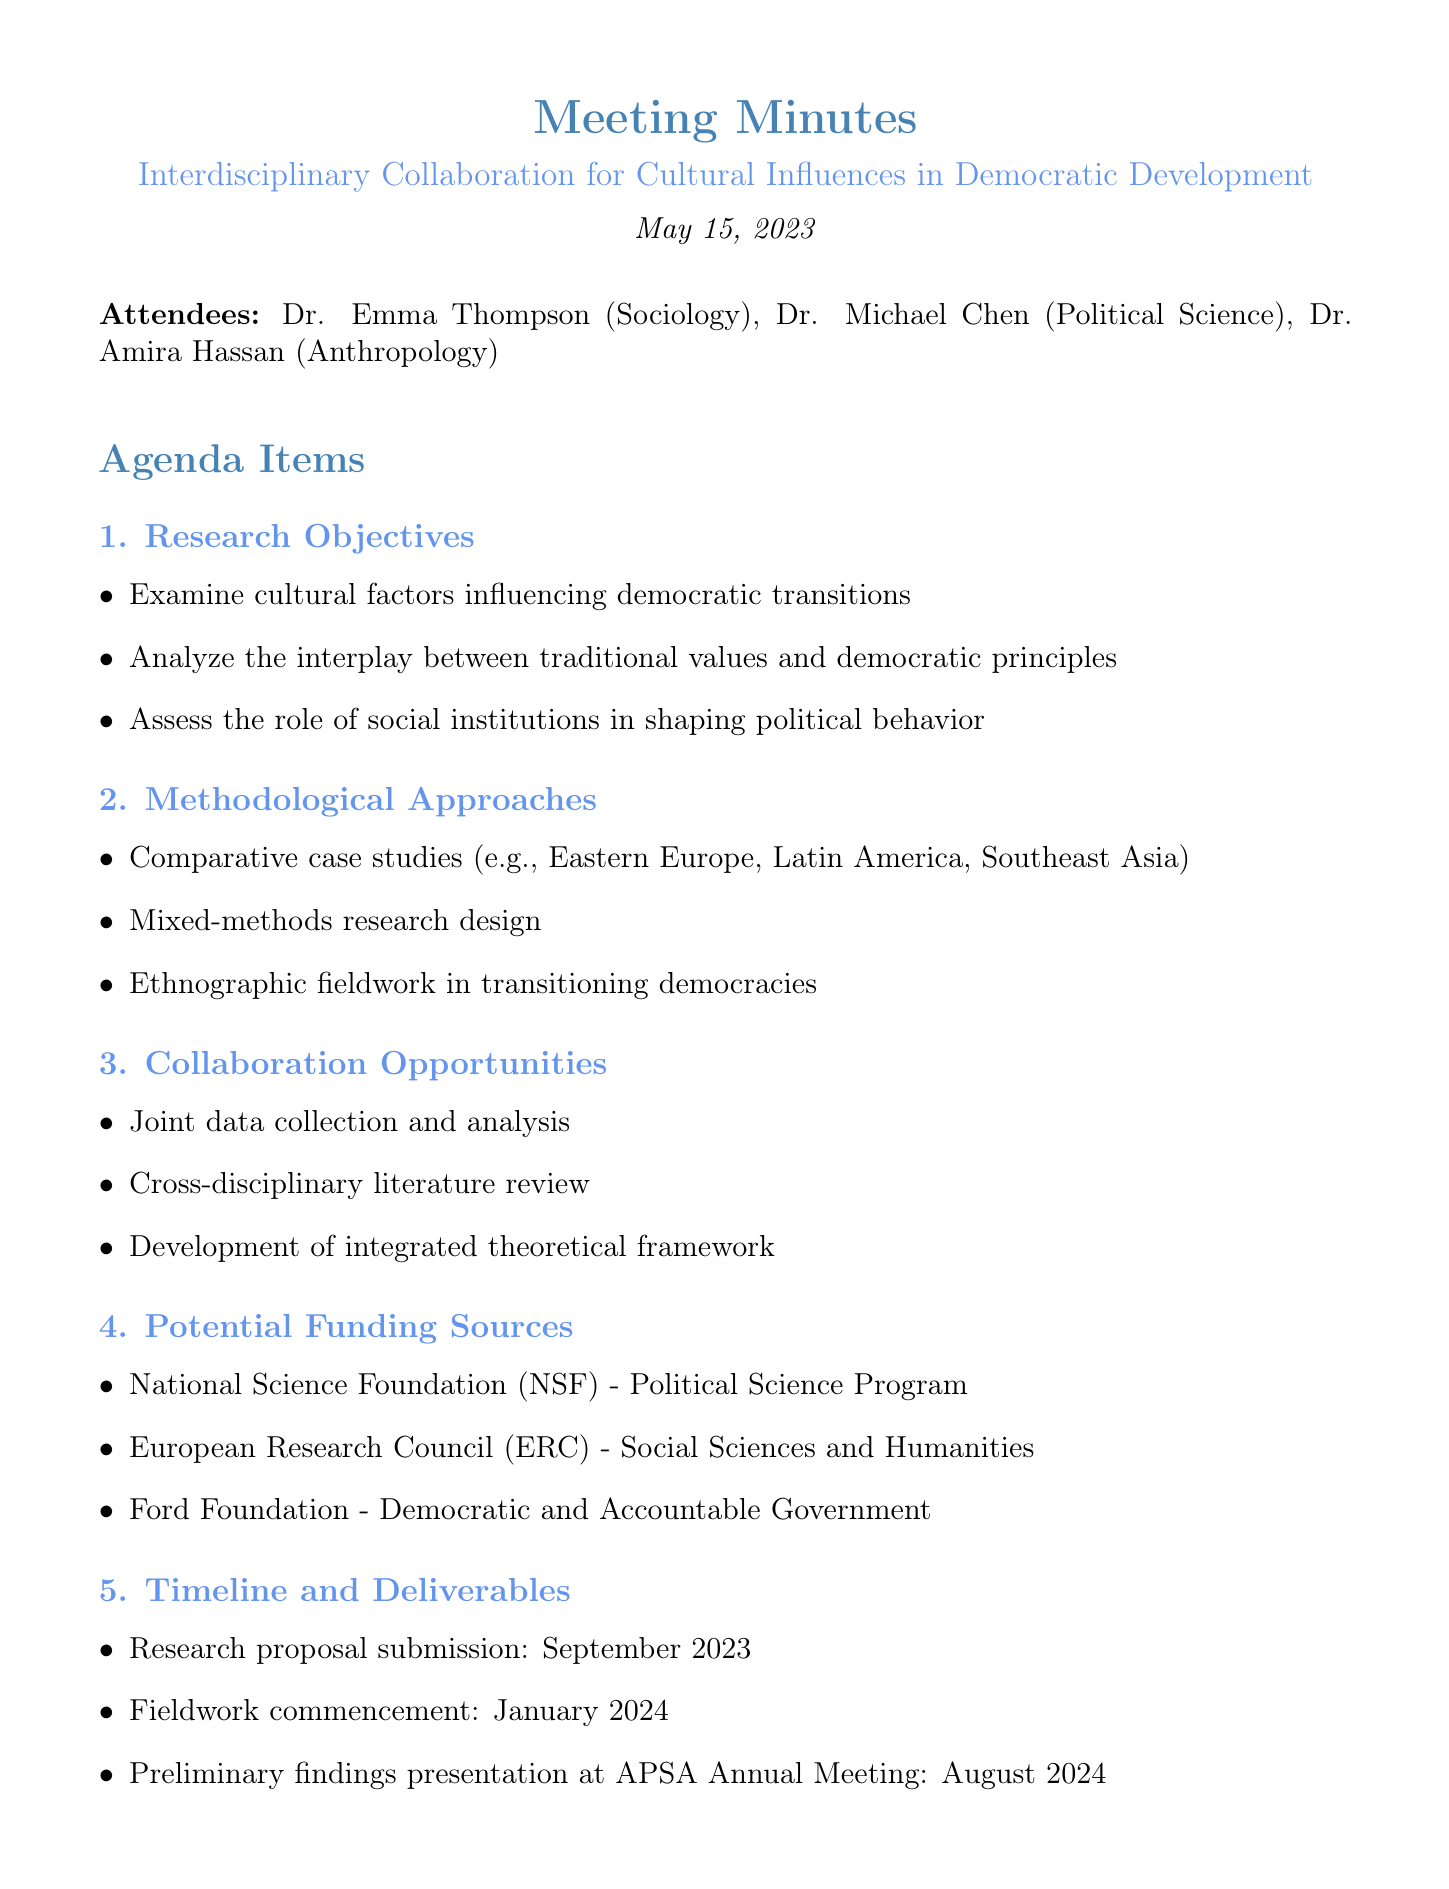What is the title of the meeting? The title is explicitly stated at the beginning of the document.
Answer: Interdisciplinary Collaboration for Cultural Influences in Democratic Development Who attended the meeting? The attendees are listed under the "Attendees" section.
Answer: Dr. Emma Thompson, Dr. Michael Chen, Dr. Amira Hassan What is one of the research objectives mentioned? The document lists specific research objectives under the "Research Objectives" section.
Answer: Examine cultural factors influencing democratic transitions When is the fieldwork expected to commence? This information is provided in the "Timeline and Deliverables" section.
Answer: January 2024 What is one potential funding source listed? Potential funding sources are noted under the "Potential Funding Sources" section.
Answer: National Science Foundation (NSF) How many action items are listed in the document? The action items are enumerated at the end of the document.
Answer: Four What methodological approach involves studying different regions? The document specifies a methodological approach pertaining to geography in the "Methodological Approaches" section.
Answer: Comparative case studies What is the deadline for all attendees to provide feedback on the draft proposal? This deadline is clearly indicated in the action items.
Answer: June 15, 2023 What type of research design is mentioned? The document outlines a specific research design type under "Methodological Approaches."
Answer: Mixed-methods research design 